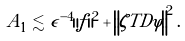<formula> <loc_0><loc_0><loc_500><loc_500>A _ { 1 } \lesssim \epsilon ^ { - 4 } \| f \| ^ { 2 } + \left \| \zeta T D \varphi \right \| ^ { 2 } .</formula> 